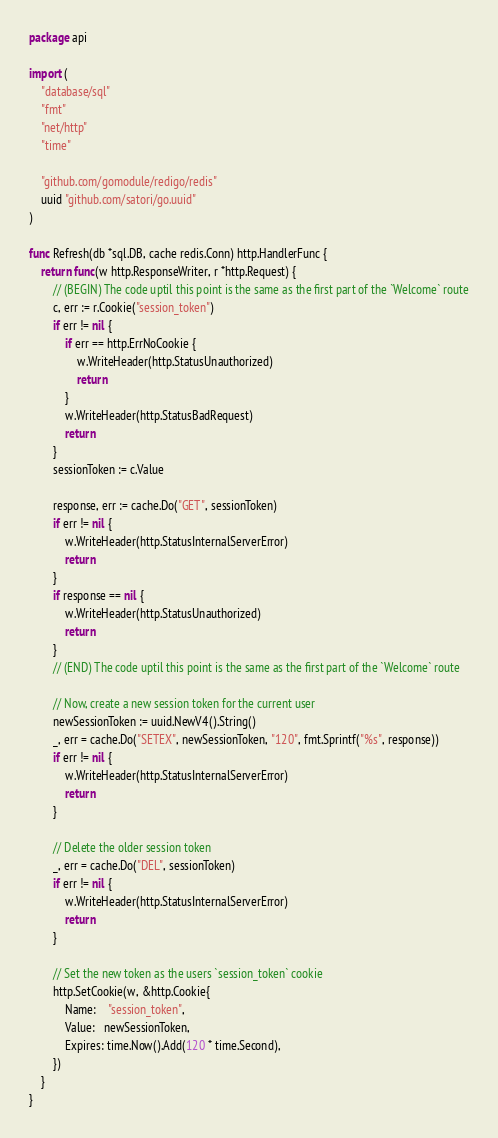<code> <loc_0><loc_0><loc_500><loc_500><_Go_>package api

import (
	"database/sql"
	"fmt"
	"net/http"
	"time"

	"github.com/gomodule/redigo/redis"
	uuid "github.com/satori/go.uuid"
)

func Refresh(db *sql.DB, cache redis.Conn) http.HandlerFunc {
	return func(w http.ResponseWriter, r *http.Request) {
		// (BEGIN) The code uptil this point is the same as the first part of the `Welcome` route
		c, err := r.Cookie("session_token")
		if err != nil {
			if err == http.ErrNoCookie {
				w.WriteHeader(http.StatusUnauthorized)
				return
			}
			w.WriteHeader(http.StatusBadRequest)
			return
		}
		sessionToken := c.Value

		response, err := cache.Do("GET", sessionToken)
		if err != nil {
			w.WriteHeader(http.StatusInternalServerError)
			return
		}
		if response == nil {
			w.WriteHeader(http.StatusUnauthorized)
			return
		}
		// (END) The code uptil this point is the same as the first part of the `Welcome` route

		// Now, create a new session token for the current user
		newSessionToken := uuid.NewV4().String()
		_, err = cache.Do("SETEX", newSessionToken, "120", fmt.Sprintf("%s", response))
		if err != nil {
			w.WriteHeader(http.StatusInternalServerError)
			return
		}

		// Delete the older session token
		_, err = cache.Do("DEL", sessionToken)
		if err != nil {
			w.WriteHeader(http.StatusInternalServerError)
			return
		}

		// Set the new token as the users `session_token` cookie
		http.SetCookie(w, &http.Cookie{
			Name:    "session_token",
			Value:   newSessionToken,
			Expires: time.Now().Add(120 * time.Second),
		})
	}
}
</code> 